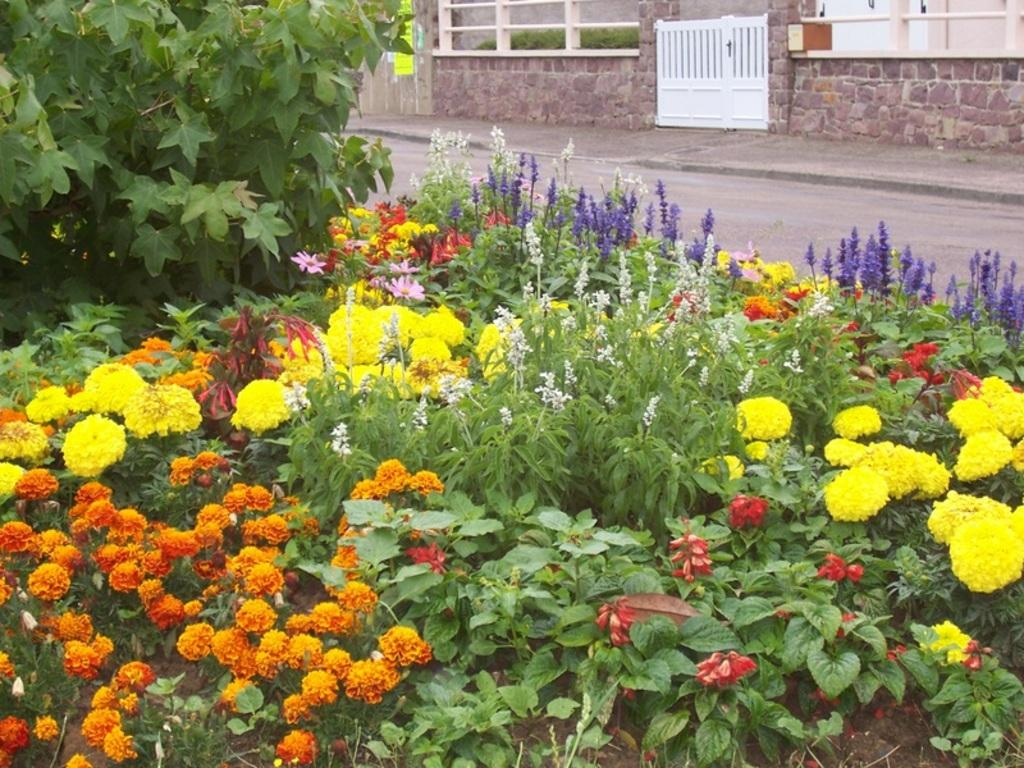What types of plants and flowers can be seen in the foreground of the image? There are different color flowers and plants in the foreground of the image. What can be seen at the top of the image? There is a road and grass visible at the top of the image. What structure is present in the image? There is a wooden gate in the image. What is the rock's house in the image? There is a rock's house in the image, which might be a small structure or a decorative element. What color does the sea burst into in the image? There is no sea present in the image, so it cannot burst into any color. 